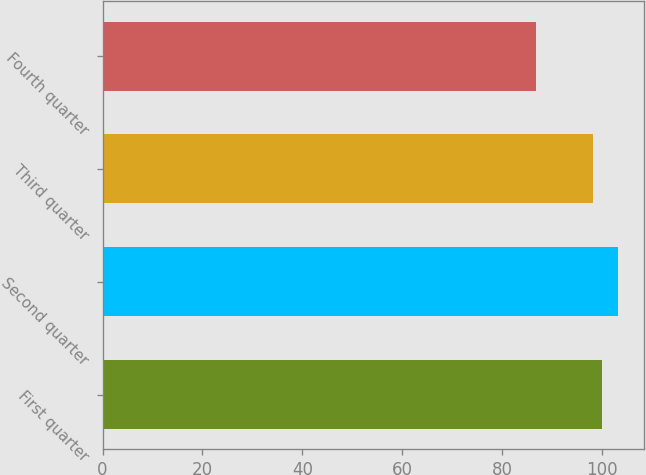Convert chart. <chart><loc_0><loc_0><loc_500><loc_500><bar_chart><fcel>First quarter<fcel>Second quarter<fcel>Third quarter<fcel>Fourth quarter<nl><fcel>99.95<fcel>103.29<fcel>98.31<fcel>86.89<nl></chart> 